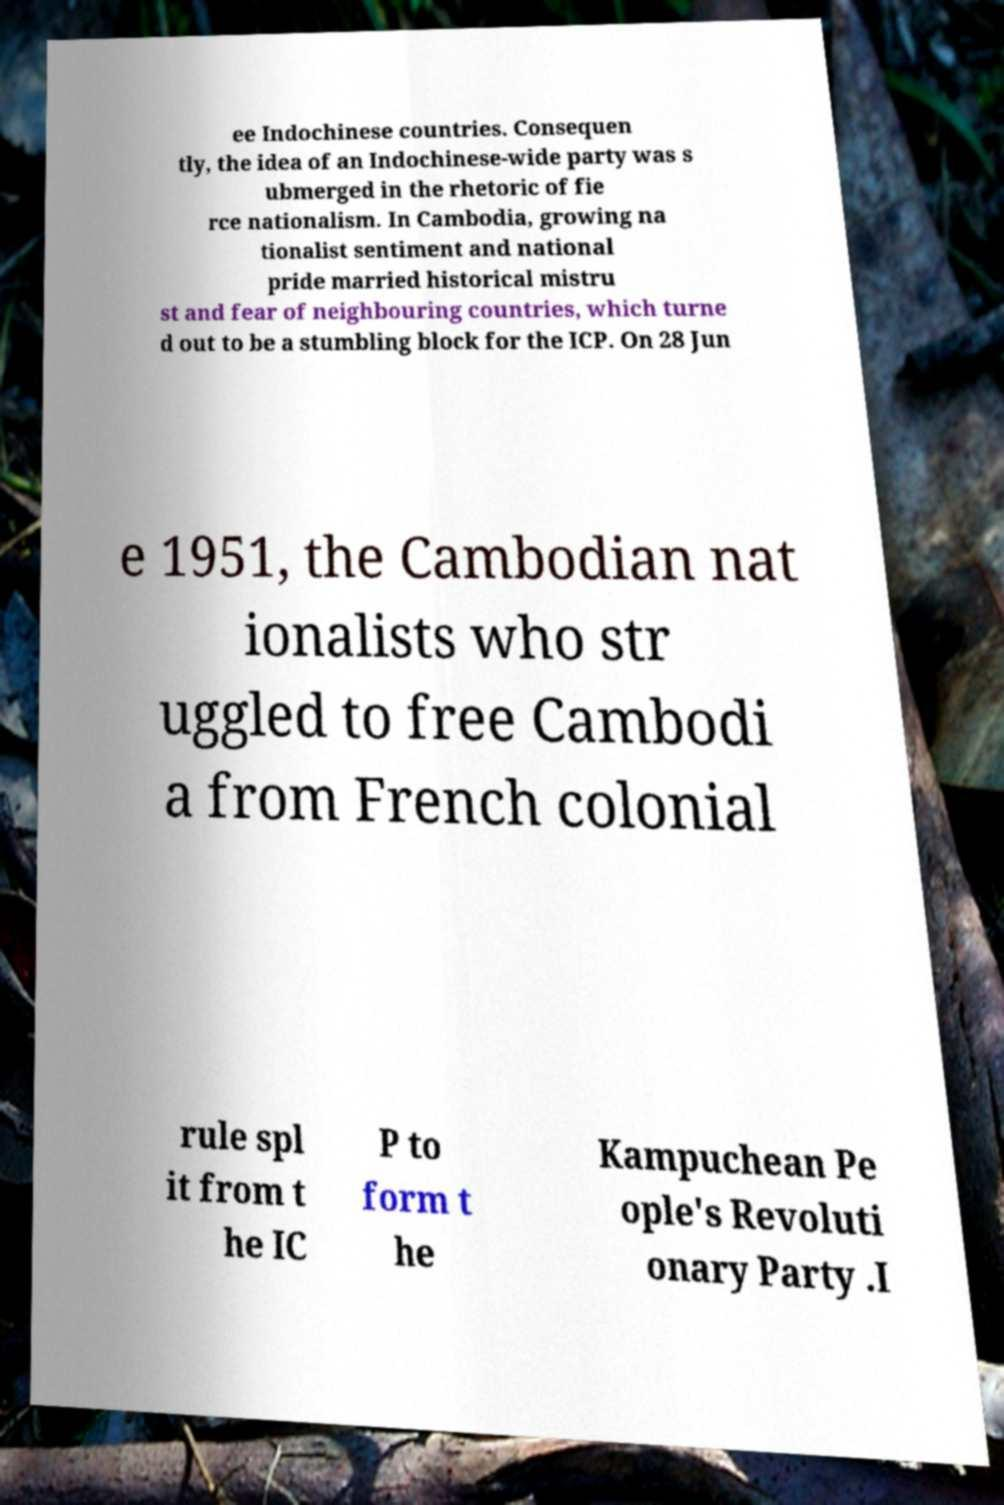There's text embedded in this image that I need extracted. Can you transcribe it verbatim? ee Indochinese countries. Consequen tly, the idea of an Indochinese-wide party was s ubmerged in the rhetoric of fie rce nationalism. In Cambodia, growing na tionalist sentiment and national pride married historical mistru st and fear of neighbouring countries, which turne d out to be a stumbling block for the ICP. On 28 Jun e 1951, the Cambodian nat ionalists who str uggled to free Cambodi a from French colonial rule spl it from t he IC P to form t he Kampuchean Pe ople's Revoluti onary Party .I 